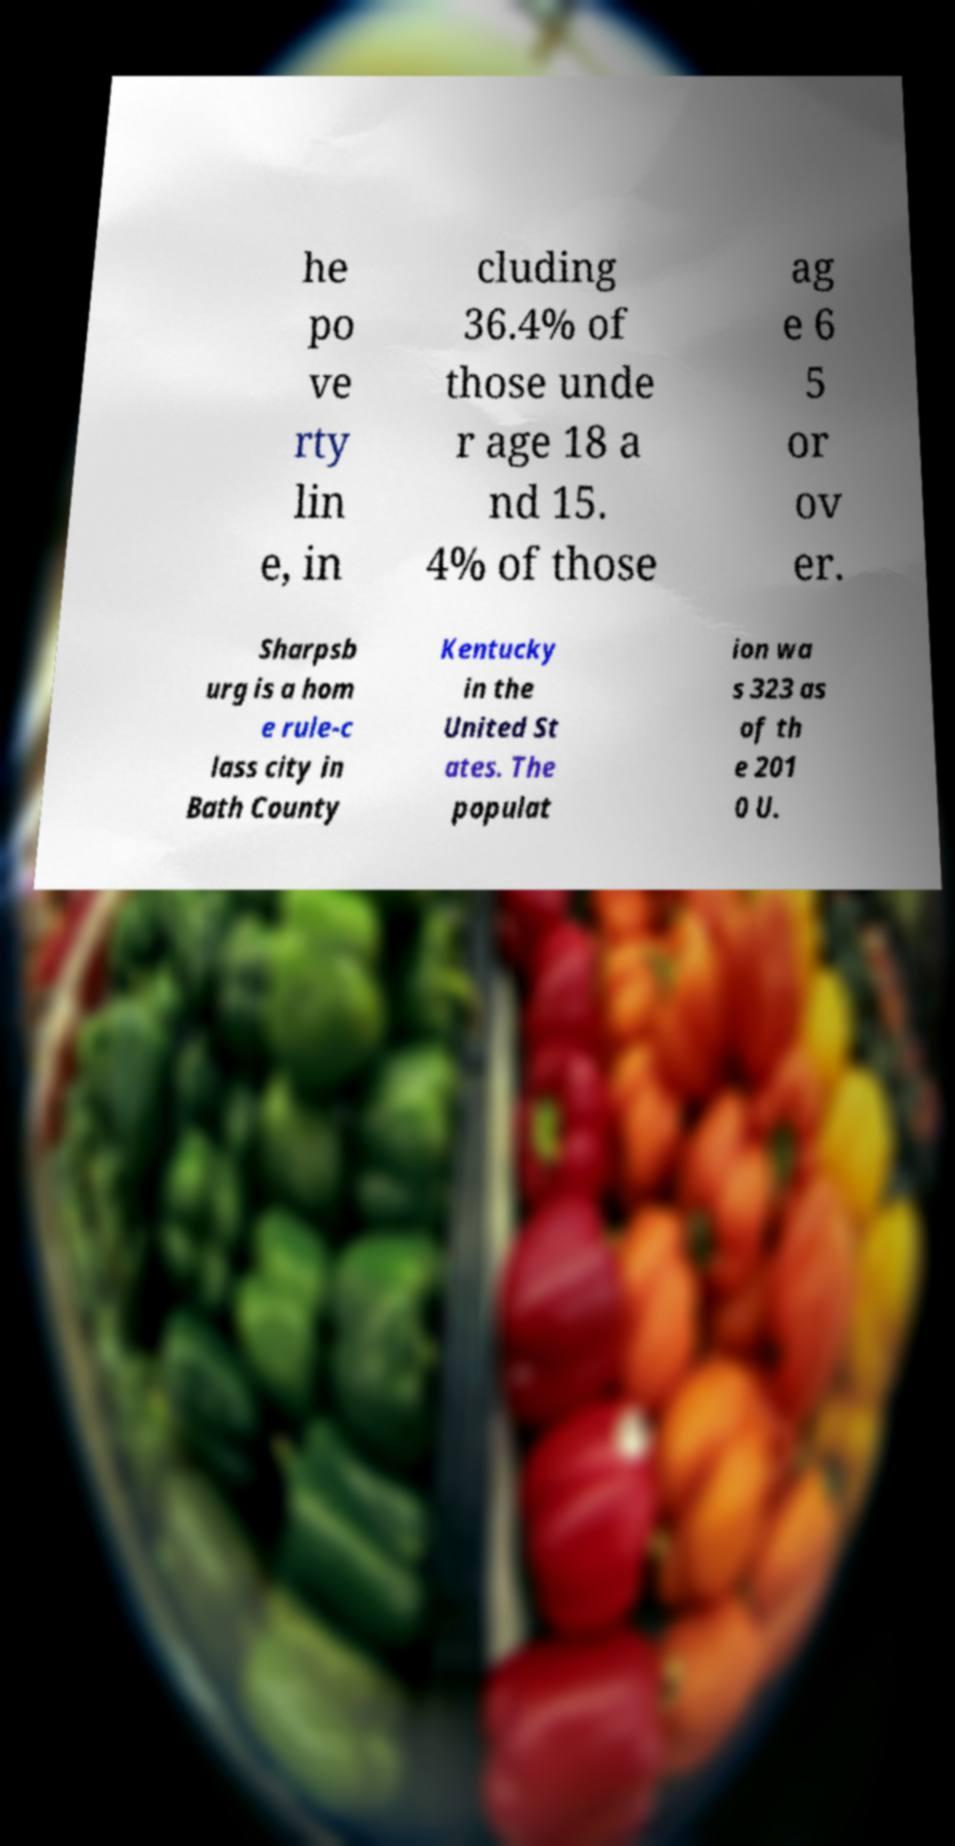Please identify and transcribe the text found in this image. he po ve rty lin e, in cluding 36.4% of those unde r age 18 a nd 15. 4% of those ag e 6 5 or ov er. Sharpsb urg is a hom e rule-c lass city in Bath County Kentucky in the United St ates. The populat ion wa s 323 as of th e 201 0 U. 